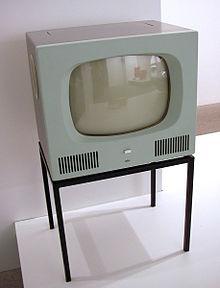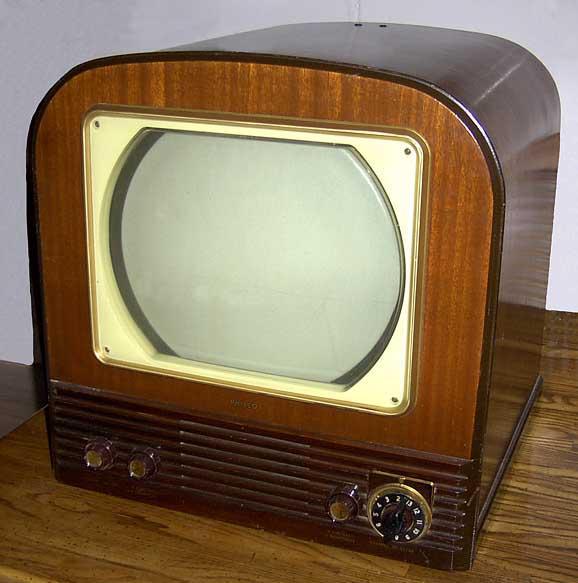The first image is the image on the left, the second image is the image on the right. Given the left and right images, does the statement "Two console televison cabinets in dark wood feature a picture tube in the upper section and speakers housed in the bottom section." hold true? Answer yes or no. No. The first image is the image on the left, the second image is the image on the right. For the images shown, is this caption "Both TVs feature small non-square screens set in boxy wood consoles, and one has a picture playing on its screen, while the other has a rich cherry finish console." true? Answer yes or no. No. 